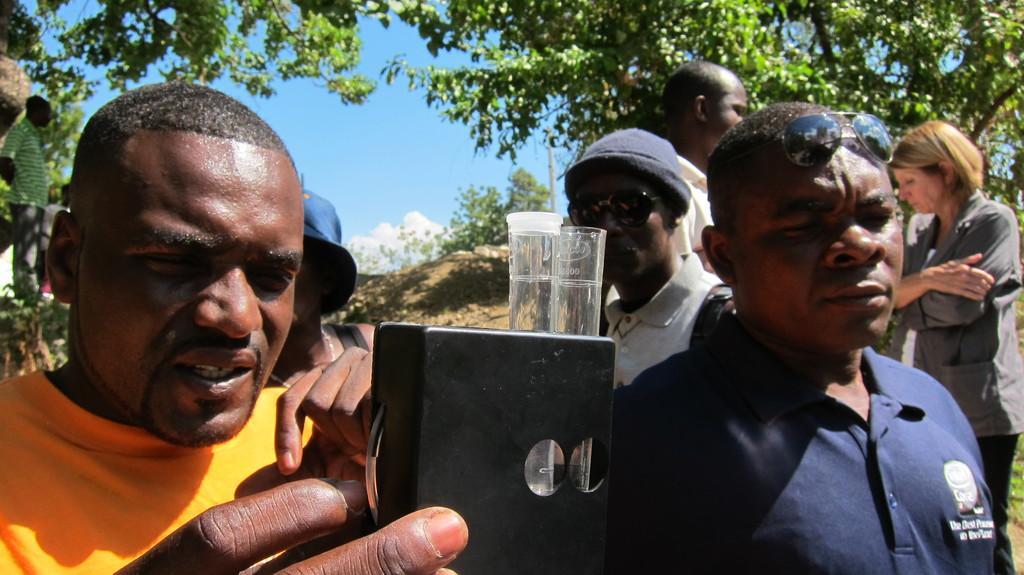Describe this image in one or two sentences. This image consists of many people. In the front, the man is holding a box in which there are two test tubes. In the background, there are trees. At the bottom, there is ground. To the right, the man is wearing blue T-shirt. 